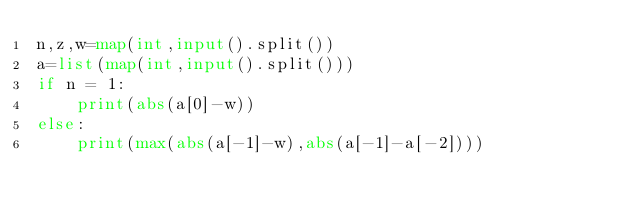Convert code to text. <code><loc_0><loc_0><loc_500><loc_500><_Python_>n,z,w=map(int,input().split())
a=list(map(int,input().split()))
if n = 1:
    print(abs(a[0]-w))
else:
    print(max(abs(a[-1]-w),abs(a[-1]-a[-2])))</code> 